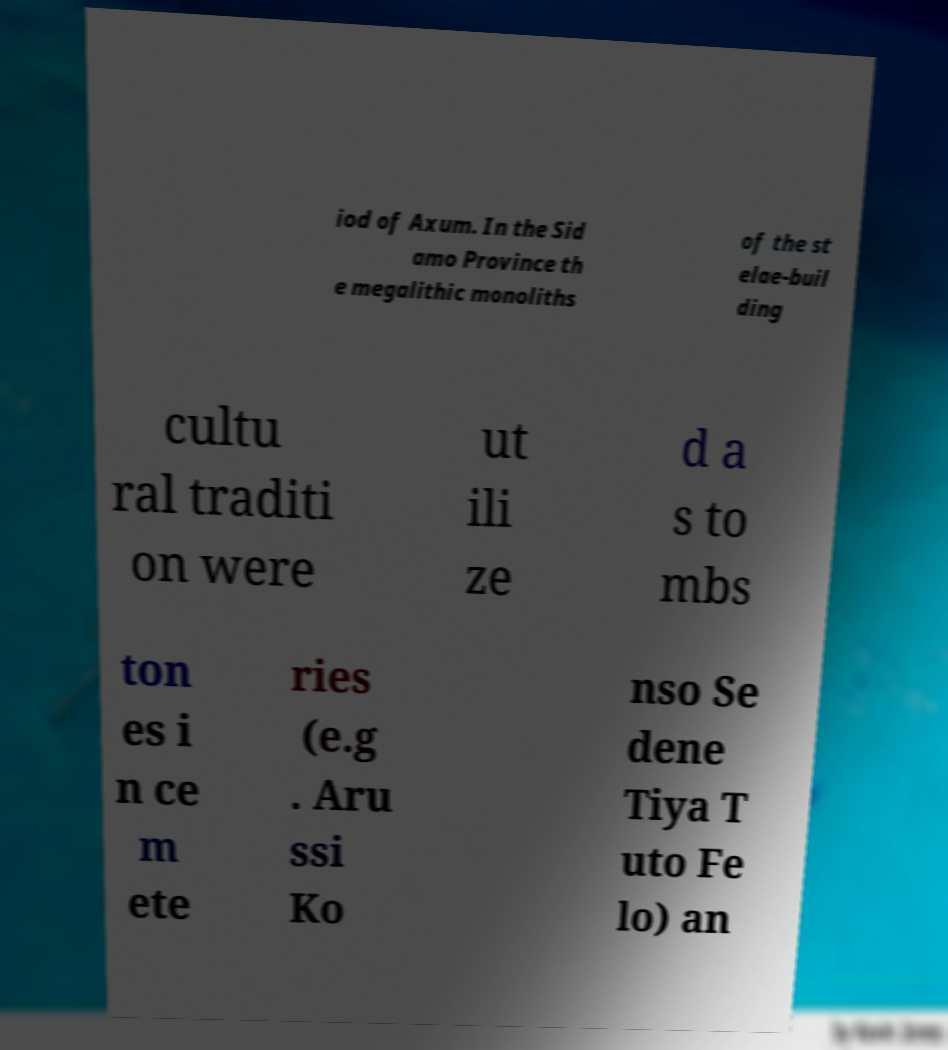Please identify and transcribe the text found in this image. iod of Axum. In the Sid amo Province th e megalithic monoliths of the st elae-buil ding cultu ral traditi on were ut ili ze d a s to mbs ton es i n ce m ete ries (e.g . Aru ssi Ko nso Se dene Tiya T uto Fe lo) an 